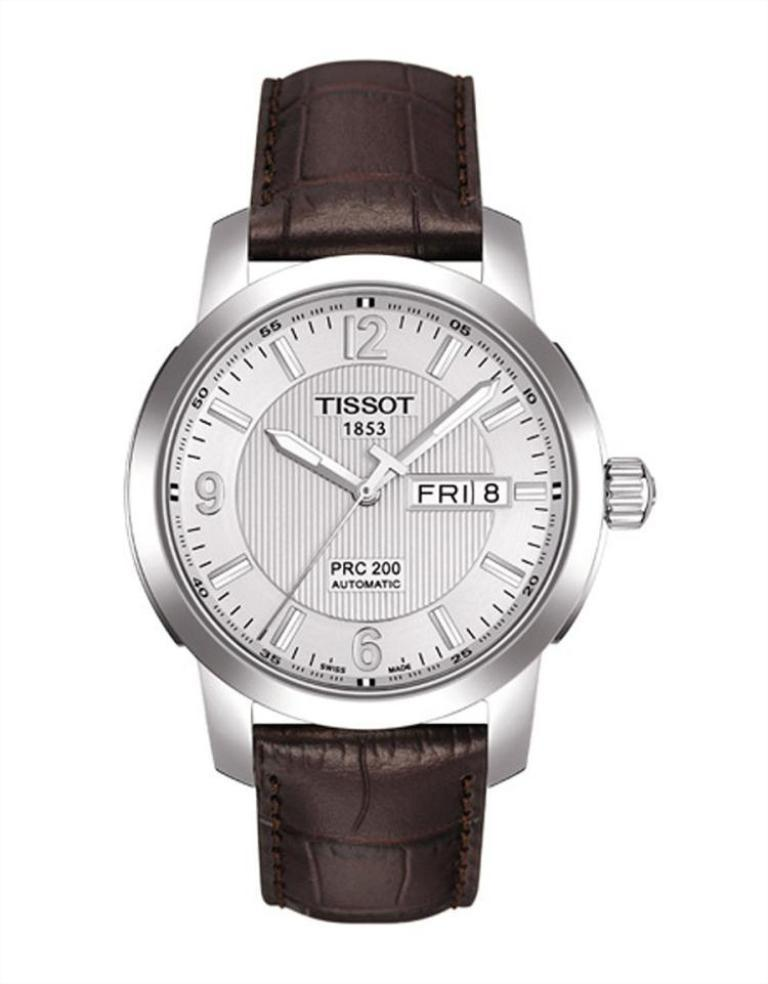<image>
Share a concise interpretation of the image provided. Silver watch that says Tissot on the face and has a brown strap. 